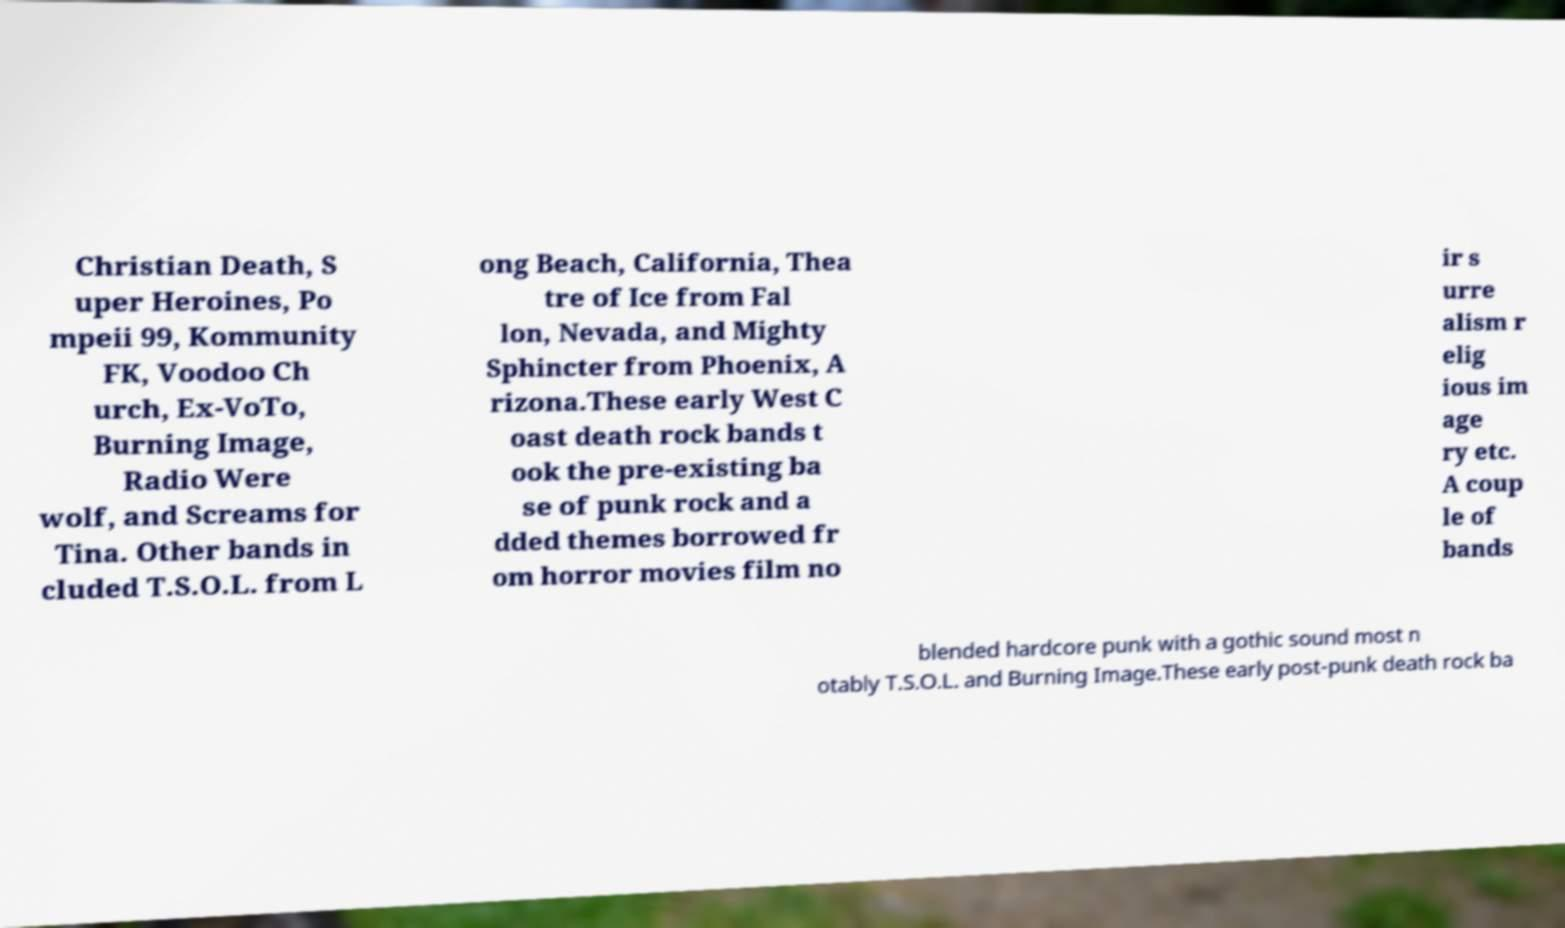There's text embedded in this image that I need extracted. Can you transcribe it verbatim? Christian Death, S uper Heroines, Po mpeii 99, Kommunity FK, Voodoo Ch urch, Ex-VoTo, Burning Image, Radio Were wolf, and Screams for Tina. Other bands in cluded T.S.O.L. from L ong Beach, California, Thea tre of Ice from Fal lon, Nevada, and Mighty Sphincter from Phoenix, A rizona.These early West C oast death rock bands t ook the pre-existing ba se of punk rock and a dded themes borrowed fr om horror movies film no ir s urre alism r elig ious im age ry etc. A coup le of bands blended hardcore punk with a gothic sound most n otably T.S.O.L. and Burning Image.These early post-punk death rock ba 